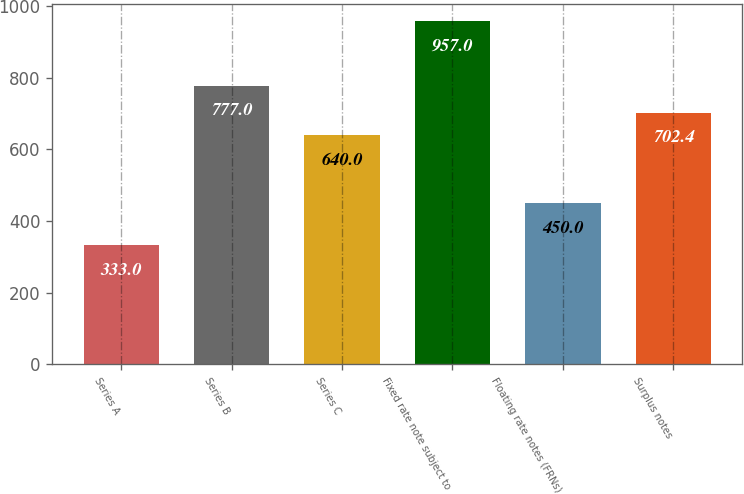Convert chart to OTSL. <chart><loc_0><loc_0><loc_500><loc_500><bar_chart><fcel>Series A<fcel>Series B<fcel>Series C<fcel>Fixed rate note subject to<fcel>Floating rate notes (FRNs)<fcel>Surplus notes<nl><fcel>333<fcel>777<fcel>640<fcel>957<fcel>450<fcel>702.4<nl></chart> 